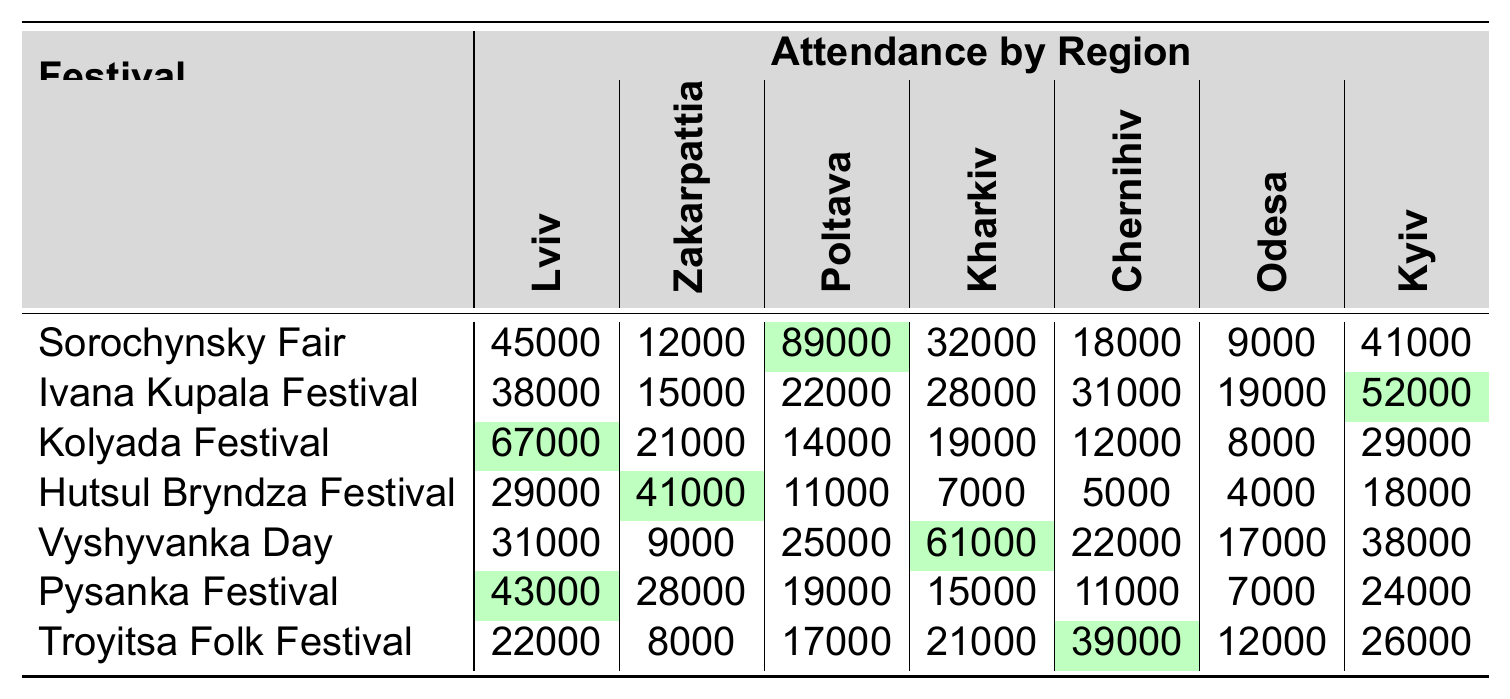What is the highest attendance recorded for a single festival in the table? The highest attendance can be found by looking across all festivals and their corresponding attendance figures. The “Sorochynsky Fair” has the highest attendance with 89,000 in Poltava Oblast.
Answer: 89,000 Which festival had the lowest attendance in Odesa Oblast? To find the lowest attendance in Odesa Oblast, we examine the column for Odesa and identify the minimum number. The “Hutsul Bryndza Festival” recorded the lowest attendance with 4,000.
Answer: 4,000 Which region had the highest attendance for the "Vyshyvanka Day"? By looking at the “Vyshyvanka Day” row, we can see the attendance for each region. Kharkiv Oblast had the highest attendance with 61,000.
Answer: 61,000 How many festivals had total attendance greater than 30,000 in Lviv Oblast? In the Lviv column, we check the attendance numbers: “Sorochynsky Fair” (45,000), “Ivana Kupala Festival” (38,000), “Kolyada Festival” (67,000), “Vyshyvanka Day” (31,000), and “Pysanka Festival” (43,000) all meet the criteria. Therefore, there are 5 festivals.
Answer: 5 Is it true that "Hutsul Bryndza Festival" had more attendees than "Pysanka Festival" in any region? By comparing the attendance in each region for both festivals, we see that Hutsul Bryndza Festival (41,000) has more attendance than Pysanka Festival (28,000) in Zakarpattia Oblast, confirming the statement is true.
Answer: Yes What is the difference in attendance between the best and worst performing festivals in Kyiv Oblast? The “Ivana Kupala Festival” has the highest attendance in Kyiv with 52,000, while the “Troyitsa Folk Festival” has the lowest with 26,000. The difference is calculated as 52,000 - 26,000 = 26,000.
Answer: 26,000 What festival had a higher total attendance in Poltava Oblast compared to Chernihiv Oblast? Comparing the attendance of the festivals, "Sorochynsky Fair" (89,000) in Poltava exceeds the highest in Chernihiv, which is "Troyitsa Folk Festival" with 39,000. Therefore, "Sorochynsky Fair" had higher total attendance.
Answer: Sorochynsky Fair Calculate the average attendance of the "Kolyada Festival". Summing the attendance figures of “Kolyada Festival” (67,000 + 21,000 + 14,000 + 19,000 + 12,000 + 8,000 + 29,000) gives 270,000. There are 7 regions, resulting in an average of 270,000 / 7 = 38,571.
Answer: 38,571 Which region had the most balanced attendance across all festivals? By calculating the variance and attendance figures for each region, Zakarpattia Oblast has relatively low variance in attendance figures, indicating more balanced attendance across festivals.
Answer: Zakarpattia Oblast Which festival had the greatest variance in attendance among the regions? To find this, we calculate the variance for each festival by determining the differences in attendance across all regions for each festival. The "Vyshyvanka Day" shows the greatest variance with attendance ranging from 9,000 to 61,000.
Answer: Vyshyvanka Day 